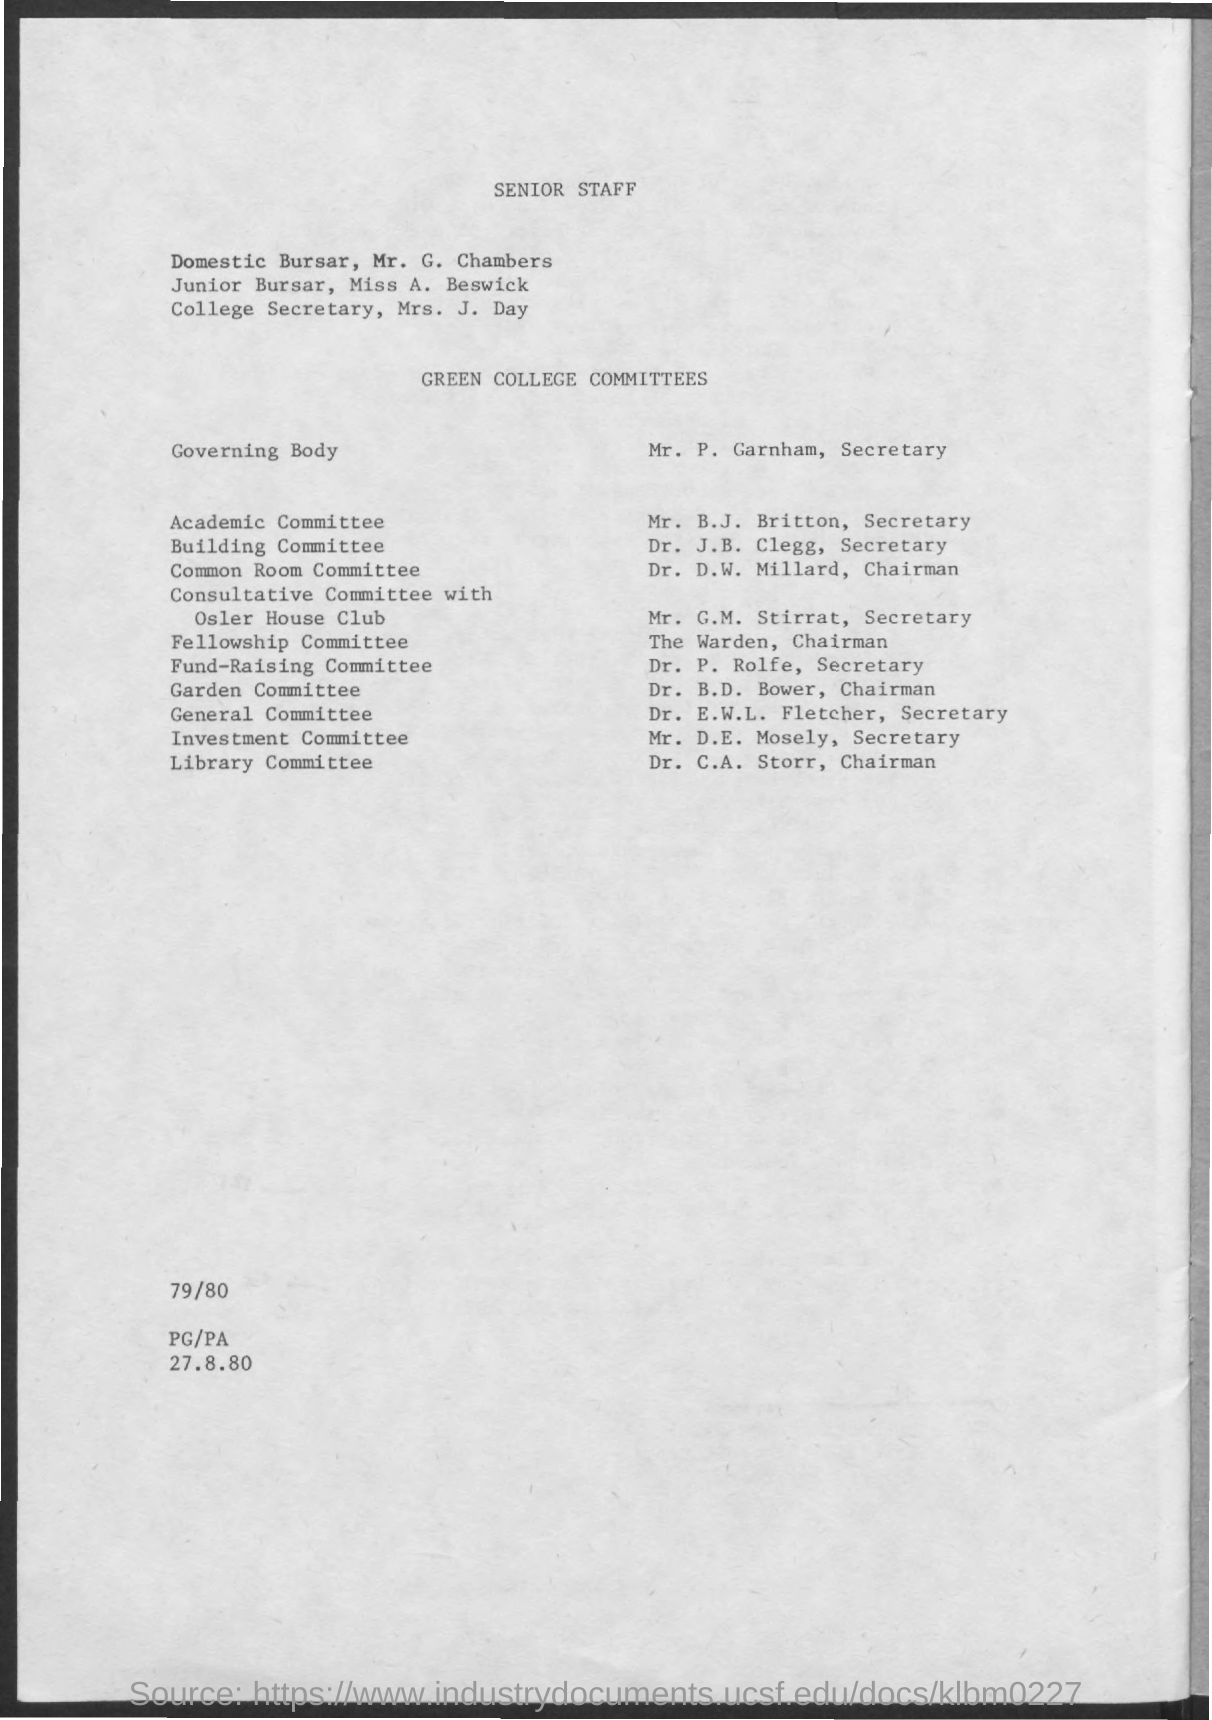Specify some key components in this picture. Dr. B.D. Bower is a member of the Garden Committee. The Warden is the chairman of the Fellowship Committee. The chairman of the Common Room Committee is Dr. D.W. Millard. The chairman of the library committee is Dr. C.A. Storr. The junior bursar's name is Miss A. Beswick. 